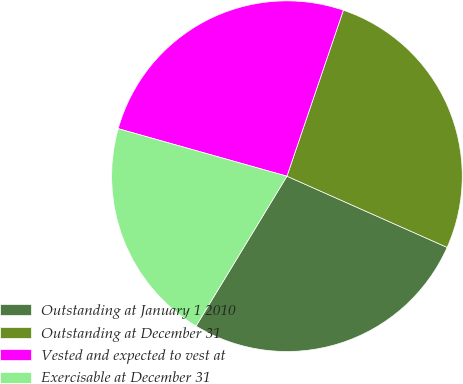Convert chart. <chart><loc_0><loc_0><loc_500><loc_500><pie_chart><fcel>Outstanding at January 1 2010<fcel>Outstanding at December 31<fcel>Vested and expected to vest at<fcel>Exercisable at December 31<nl><fcel>27.02%<fcel>26.44%<fcel>25.85%<fcel>20.69%<nl></chart> 